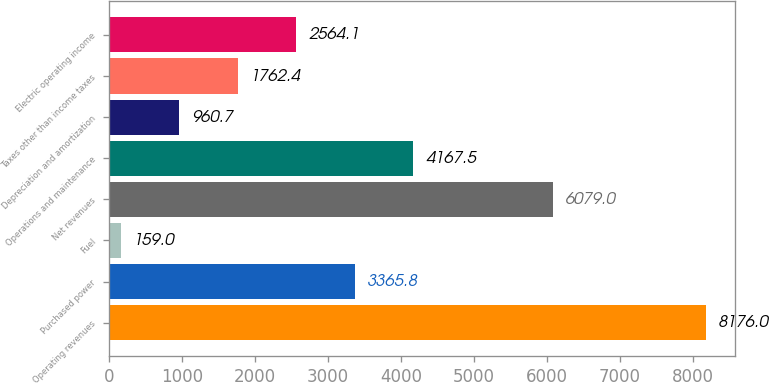Convert chart to OTSL. <chart><loc_0><loc_0><loc_500><loc_500><bar_chart><fcel>Operating revenues<fcel>Purchased power<fcel>Fuel<fcel>Net revenues<fcel>Operations and maintenance<fcel>Depreciation and amortization<fcel>Taxes other than income taxes<fcel>Electric operating income<nl><fcel>8176<fcel>3365.8<fcel>159<fcel>6079<fcel>4167.5<fcel>960.7<fcel>1762.4<fcel>2564.1<nl></chart> 